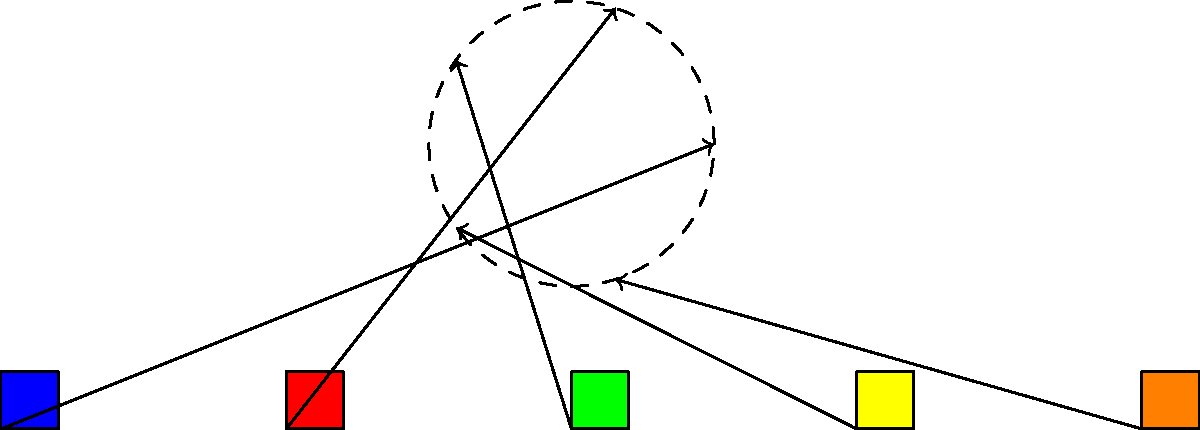As a UN representative organizing a diplomatic circle, you need to arrange five country flags equally spaced around a circular table. The flags are initially placed in a horizontal line, 10 units apart. If the circular table has a radius of 5 units and its center is 10 units above the middle flag, what is the translation vector for moving the rightmost flag to its position in the diplomatic circle? Let's approach this step-by-step:

1) The initial positions of the flags are (0,0), (10,0), (20,0), (30,0), and (40,0).

2) The center of the circular table is at (20,10), which is 10 units above the middle flag.

3) The flags will be arranged around the circle at angles of 0°, 72°, 144°, 216°, and 288° (360° ÷ 5 = 72°).

4) The rightmost flag is initially at (40,0) and needs to move to the position at 288° on the circle.

5) The new position can be calculated using polar coordinates:
   x = 20 + 5 * cos(288°)
   y = 10 + 5 * sin(288°)

6) Using a calculator or programming language:
   x ≈ 20 + 5 * 0.309 = 21.545
   y ≈ 10 + 5 * (-0.951) = 5.245

7) The translation vector is the difference between the new position and the original position:
   $$(21.545 - 40, 5.245 - 0) = (-18.455, 5.245)$$

Therefore, the translation vector is approximately $(-18.455, 5.245)$.
Answer: $(-18.455, 5.245)$ 